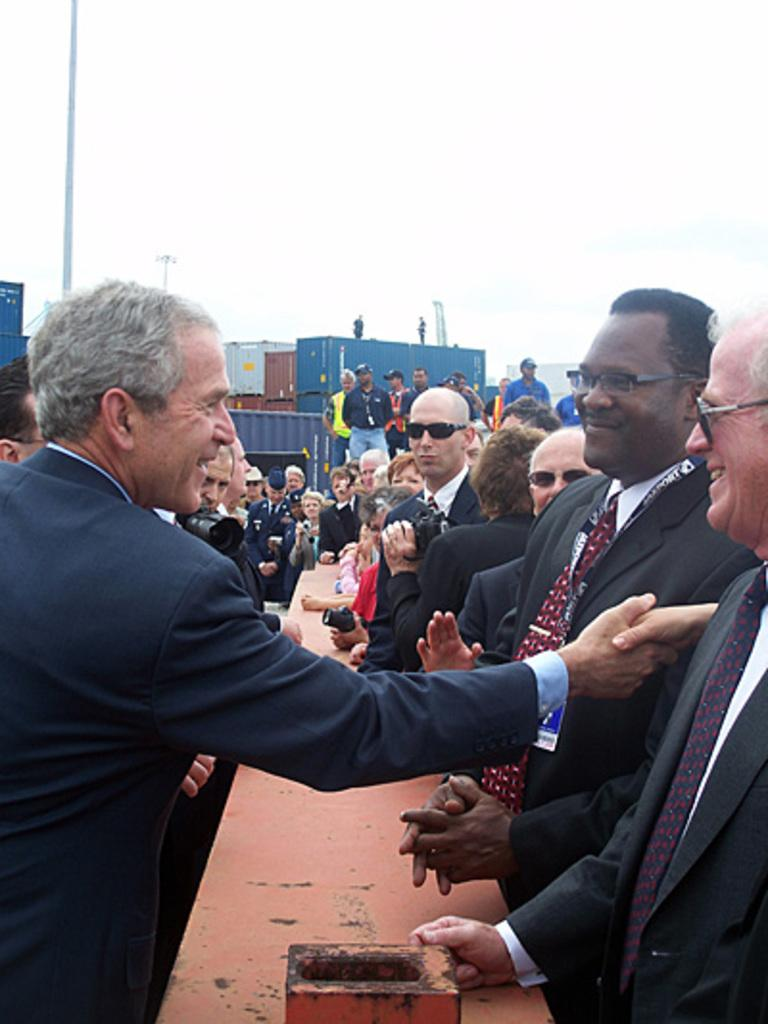Who is the man interacting with on the left side of the image? The man is shaking hands with someone. What is the man wearing in the image? The man is wearing a coat. What are the people on the right side of the image doing? The people on the right side are standing and smiling. What is visible at the top of the image? The sky is visible at the top of the image. What type of potato is being held by the man on the left side of the image? There is no potato present in the image; the man is shaking hands with someone. How many apples can be seen in the image? There are no apples present in the image. 